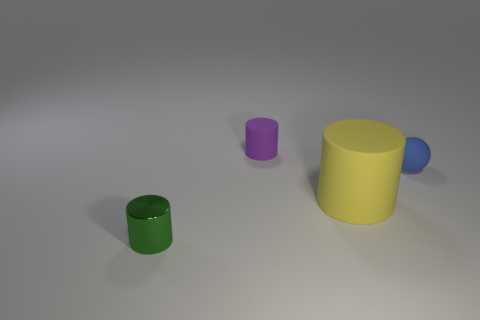Subtract all tiny cylinders. How many cylinders are left? 1 Add 2 big yellow matte cylinders. How many objects exist? 6 Subtract all purple cylinders. How many cylinders are left? 2 Subtract 2 cylinders. How many cylinders are left? 1 Subtract 0 yellow blocks. How many objects are left? 4 Subtract all spheres. How many objects are left? 3 Subtract all yellow cylinders. Subtract all purple blocks. How many cylinders are left? 2 Subtract all yellow cylinders. How many brown spheres are left? 0 Subtract all small green metallic objects. Subtract all green metallic cylinders. How many objects are left? 2 Add 3 small purple cylinders. How many small purple cylinders are left? 4 